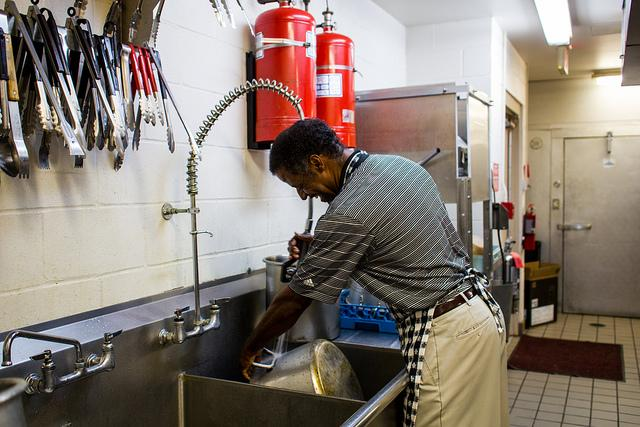What items are hanging on the wall? Please explain your reasoning. tongs. The kitchen has tongs hanging on the wall next to the man washing pots. the shape and makeup of the tongs is visible and is clear. 